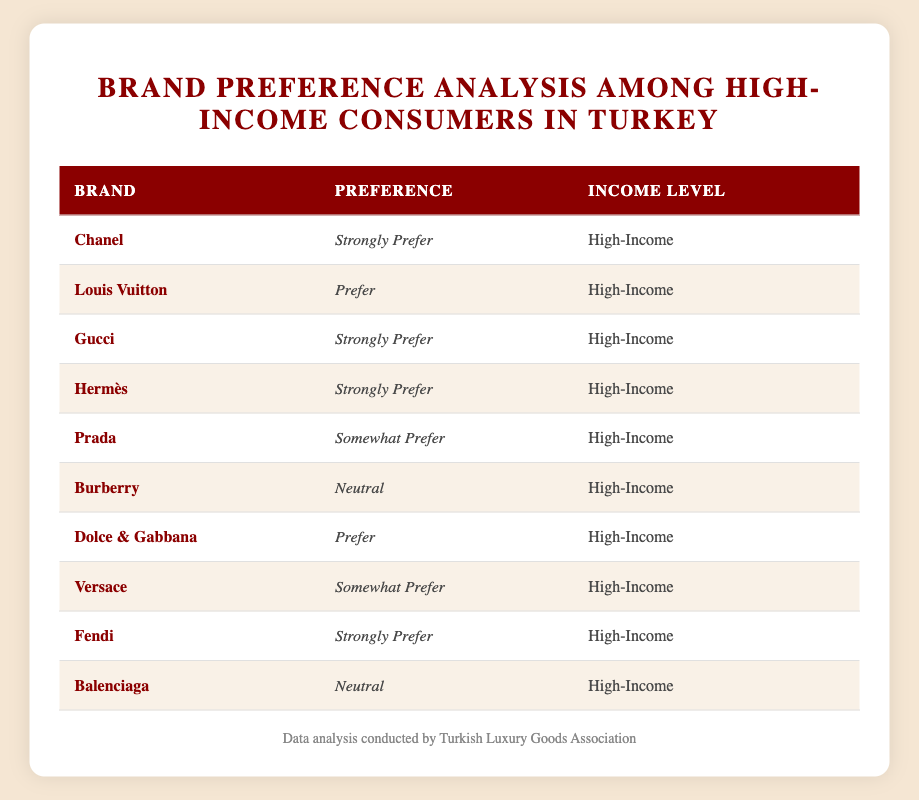What brand has the highest preference among high-income consumers? From the table, we see that "Chanel," "Gucci," "Hermès," and "Fendi" are all listed as "Strongly Prefer." Since multiple brands share this status, the highest preference cannot be limited to one brand but includes all of them.
Answer: Chanel, Gucci, Hermès, Fendi How many brands are categorized as "Neutral" in their preference among high-income consumers? In the table, the brands listed as "Neutral" are "Burberry" and "Balenciaga." By counting these entries, we find that there are 2 brands in total.
Answer: 2 Which brands do high-income consumers "Somewhat Prefer"? The brands listed in the table under the preference category "Somewhat Prefer" are "Prada" and "Versace." These brands reflect a lukewarm preference among high-income consumers.
Answer: Prada, Versace Is there any brand that is both "Strongly Prefer" and "Prefer" among high-income consumers? Evaluating the table shows that "Strongly Prefer" includes multiple brands while "Prefer" includes "Louis Vuitton" and "Dolce & Gabbana." Since these preferences are distinct and do not overlap, no brand is categorized as both.
Answer: No What is the total number of brands represented in the table? The table lists a total of 10 brands in the "Brand" column. Each entry corresponds to a unique luxury brand aimed at high-income consumers.
Answer: 10 What percentage of the brands fall under the "Strongly Prefer" category? There are 4 brands that are "Strongly Prefer" out of 10 total brands (Chanel, Gucci, Hermès, Fendi). To find the percentage, we calculate (4/10) * 100 = 40%.
Answer: 40% Which brand has a "Prefer" rating and how does it compare with the "Strongly Prefer" brands? The brands with a "Prefer" rating are "Louis Vuitton" and "Dolce & Gabbana," while the brands with a "Strongly Prefer" rating are "Chanel," "Gucci," "Hermès," and "Fendi." This shows that only a portion of high-income consumers rank these brands lower than the preferred brands.
Answer: Louis Vuitton, Dolce & Gabbana Among the brands that are "Somewhat Prefer," which one has a higher preference? The brands that fall under the "Somewhat Prefer" category are "Prada" and "Versace." Since there is no further ranking provided, we consider them equal in this preference category.
Answer: Equal preference Are any of the brands that high-income consumers purchase listed as "Prefer" also categorized as "Neutral"? The brands in the "Prefer" category are "Louis Vuitton" and "Dolce & Gabbana," while "Neutral" includes "Burberry" and "Balenciaga." Since there are no overlaps between these categories, the answer is no.
Answer: No 